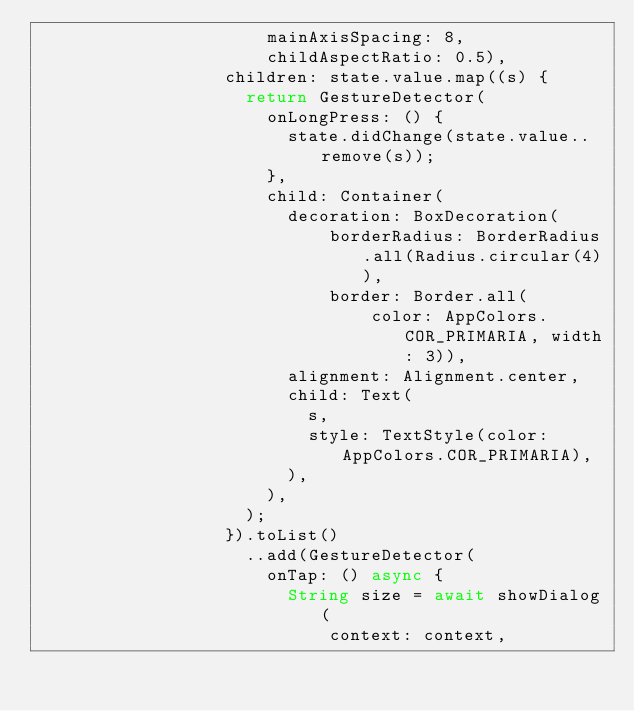<code> <loc_0><loc_0><loc_500><loc_500><_Dart_>                      mainAxisSpacing: 8,
                      childAspectRatio: 0.5),
                  children: state.value.map((s) {
                    return GestureDetector(
                      onLongPress: () {
                        state.didChange(state.value..remove(s));
                      },
                      child: Container(
                        decoration: BoxDecoration(
                            borderRadius: BorderRadius.all(Radius.circular(4)),
                            border: Border.all(
                                color: AppColors.COR_PRIMARIA, width: 3)),
                        alignment: Alignment.center,
                        child: Text(
                          s,
                          style: TextStyle(color: AppColors.COR_PRIMARIA),
                        ),
                      ),
                    );
                  }).toList()
                    ..add(GestureDetector(
                      onTap: () async {
                        String size = await showDialog(
                            context: context,</code> 